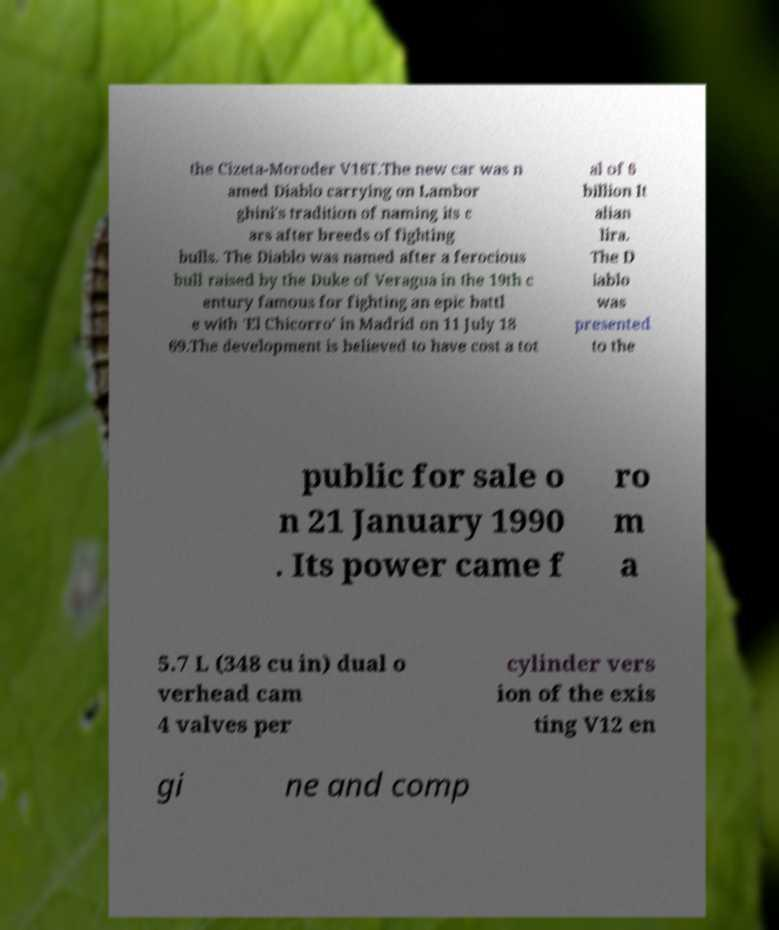Please read and relay the text visible in this image. What does it say? the Cizeta-Moroder V16T.The new car was n amed Diablo carrying on Lambor ghini's tradition of naming its c ars after breeds of fighting bulls. The Diablo was named after a ferocious bull raised by the Duke of Veragua in the 19th c entury famous for fighting an epic battl e with 'El Chicorro' in Madrid on 11 July 18 69.The development is believed to have cost a tot al of 6 billion It alian lira. The D iablo was presented to the public for sale o n 21 January 1990 . Its power came f ro m a 5.7 L (348 cu in) dual o verhead cam 4 valves per cylinder vers ion of the exis ting V12 en gi ne and comp 